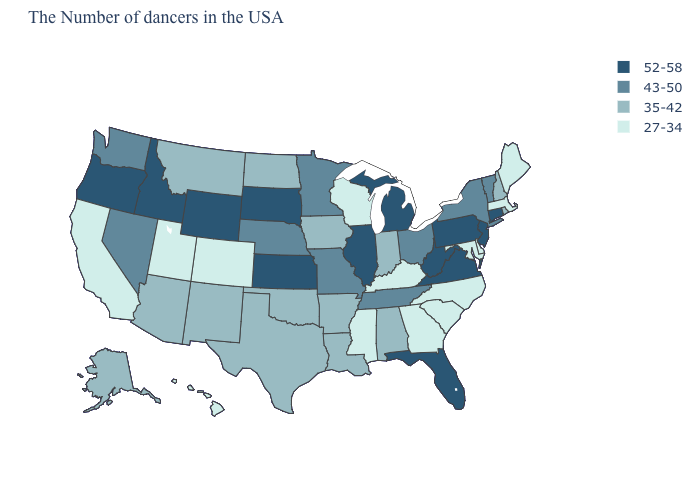Does Michigan have a lower value than New York?
Quick response, please. No. What is the value of New Hampshire?
Keep it brief. 35-42. Name the states that have a value in the range 35-42?
Concise answer only. Rhode Island, New Hampshire, Indiana, Alabama, Louisiana, Arkansas, Iowa, Oklahoma, Texas, North Dakota, New Mexico, Montana, Arizona, Alaska. Name the states that have a value in the range 43-50?
Be succinct. Vermont, New York, Ohio, Tennessee, Missouri, Minnesota, Nebraska, Nevada, Washington. What is the value of Idaho?
Write a very short answer. 52-58. What is the highest value in the USA?
Short answer required. 52-58. How many symbols are there in the legend?
Give a very brief answer. 4. Among the states that border Iowa , which have the lowest value?
Quick response, please. Wisconsin. What is the value of New York?
Write a very short answer. 43-50. Does Wyoming have the highest value in the West?
Write a very short answer. Yes. What is the value of Hawaii?
Be succinct. 27-34. What is the lowest value in the MidWest?
Concise answer only. 27-34. How many symbols are there in the legend?
Write a very short answer. 4. What is the value of Utah?
Quick response, please. 27-34. 